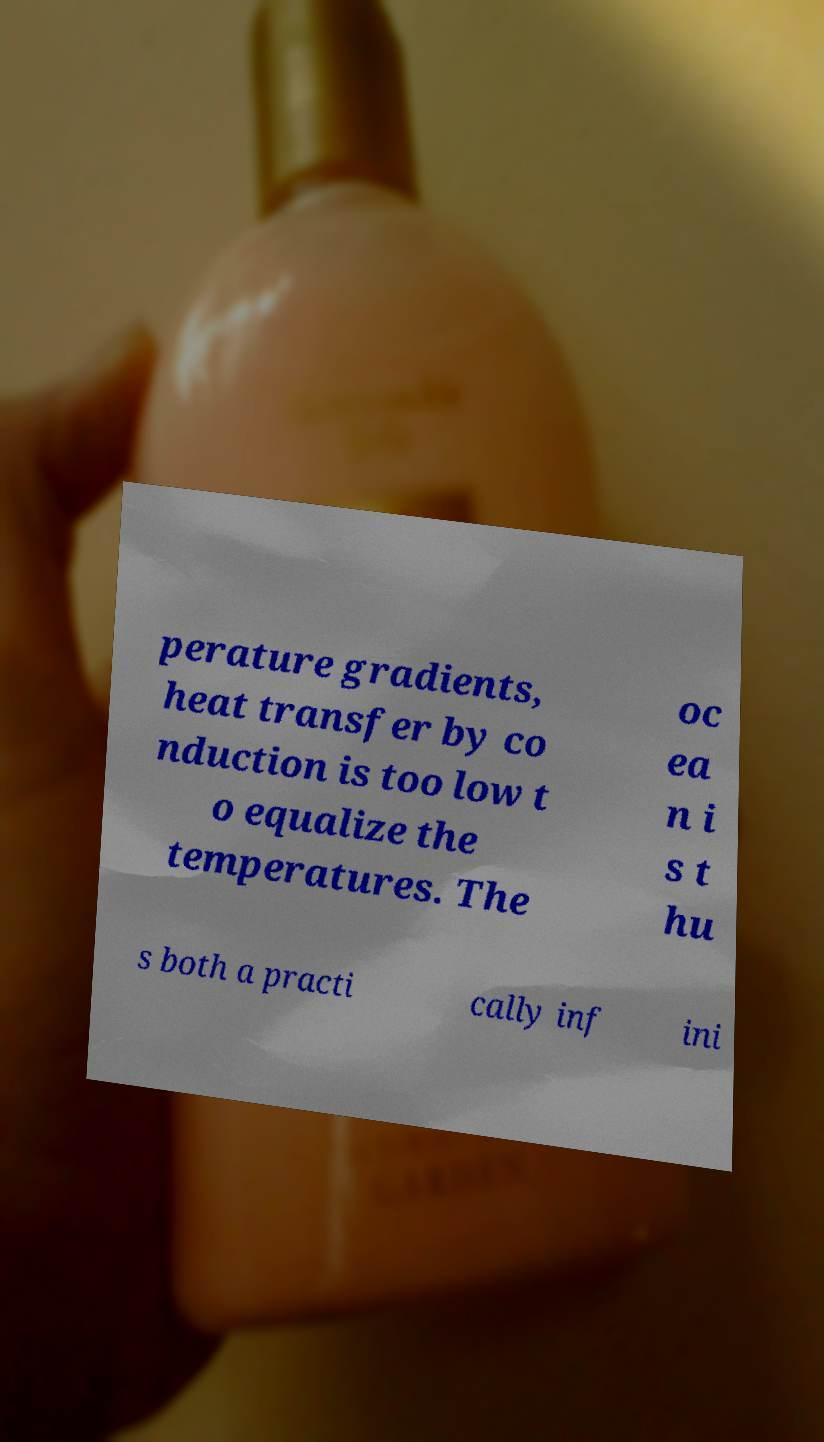Please identify and transcribe the text found in this image. perature gradients, heat transfer by co nduction is too low t o equalize the temperatures. The oc ea n i s t hu s both a practi cally inf ini 